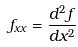<formula> <loc_0><loc_0><loc_500><loc_500>f _ { x x } = \frac { d ^ { 2 } f } { d x ^ { 2 } }</formula> 